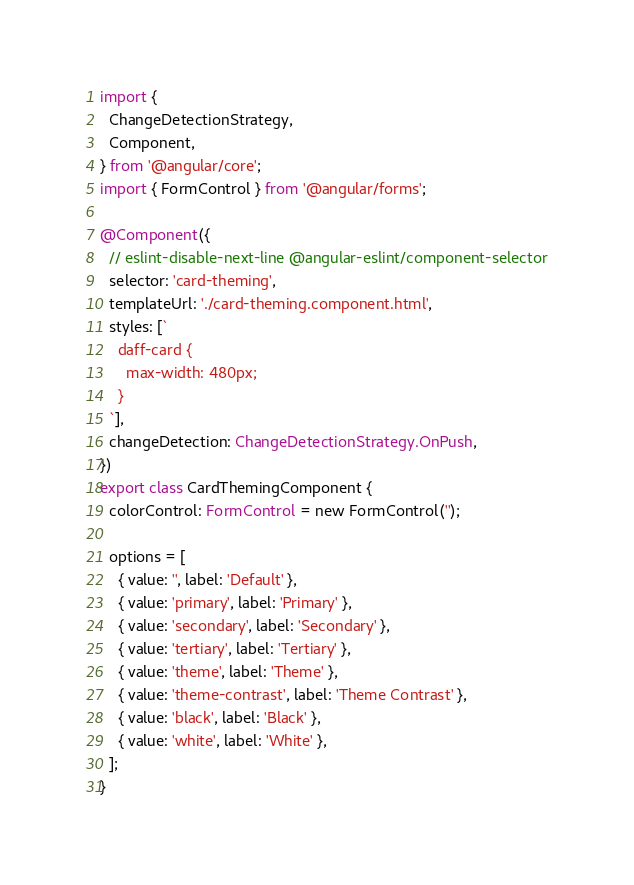Convert code to text. <code><loc_0><loc_0><loc_500><loc_500><_TypeScript_>import {
  ChangeDetectionStrategy,
  Component,
} from '@angular/core';
import { FormControl } from '@angular/forms';

@Component({
  // eslint-disable-next-line @angular-eslint/component-selector
  selector: 'card-theming',
  templateUrl: './card-theming.component.html',
  styles: [`
    daff-card {
      max-width: 480px;
    }
  `],
  changeDetection: ChangeDetectionStrategy.OnPush,
})
export class CardThemingComponent {
  colorControl: FormControl = new FormControl('');

  options = [
    { value: '', label: 'Default' },
    { value: 'primary', label: 'Primary' },
    { value: 'secondary', label: 'Secondary' },
    { value: 'tertiary', label: 'Tertiary' },
    { value: 'theme', label: 'Theme' },
    { value: 'theme-contrast', label: 'Theme Contrast' },
    { value: 'black', label: 'Black' },
    { value: 'white', label: 'White' },
  ];
}
</code> 